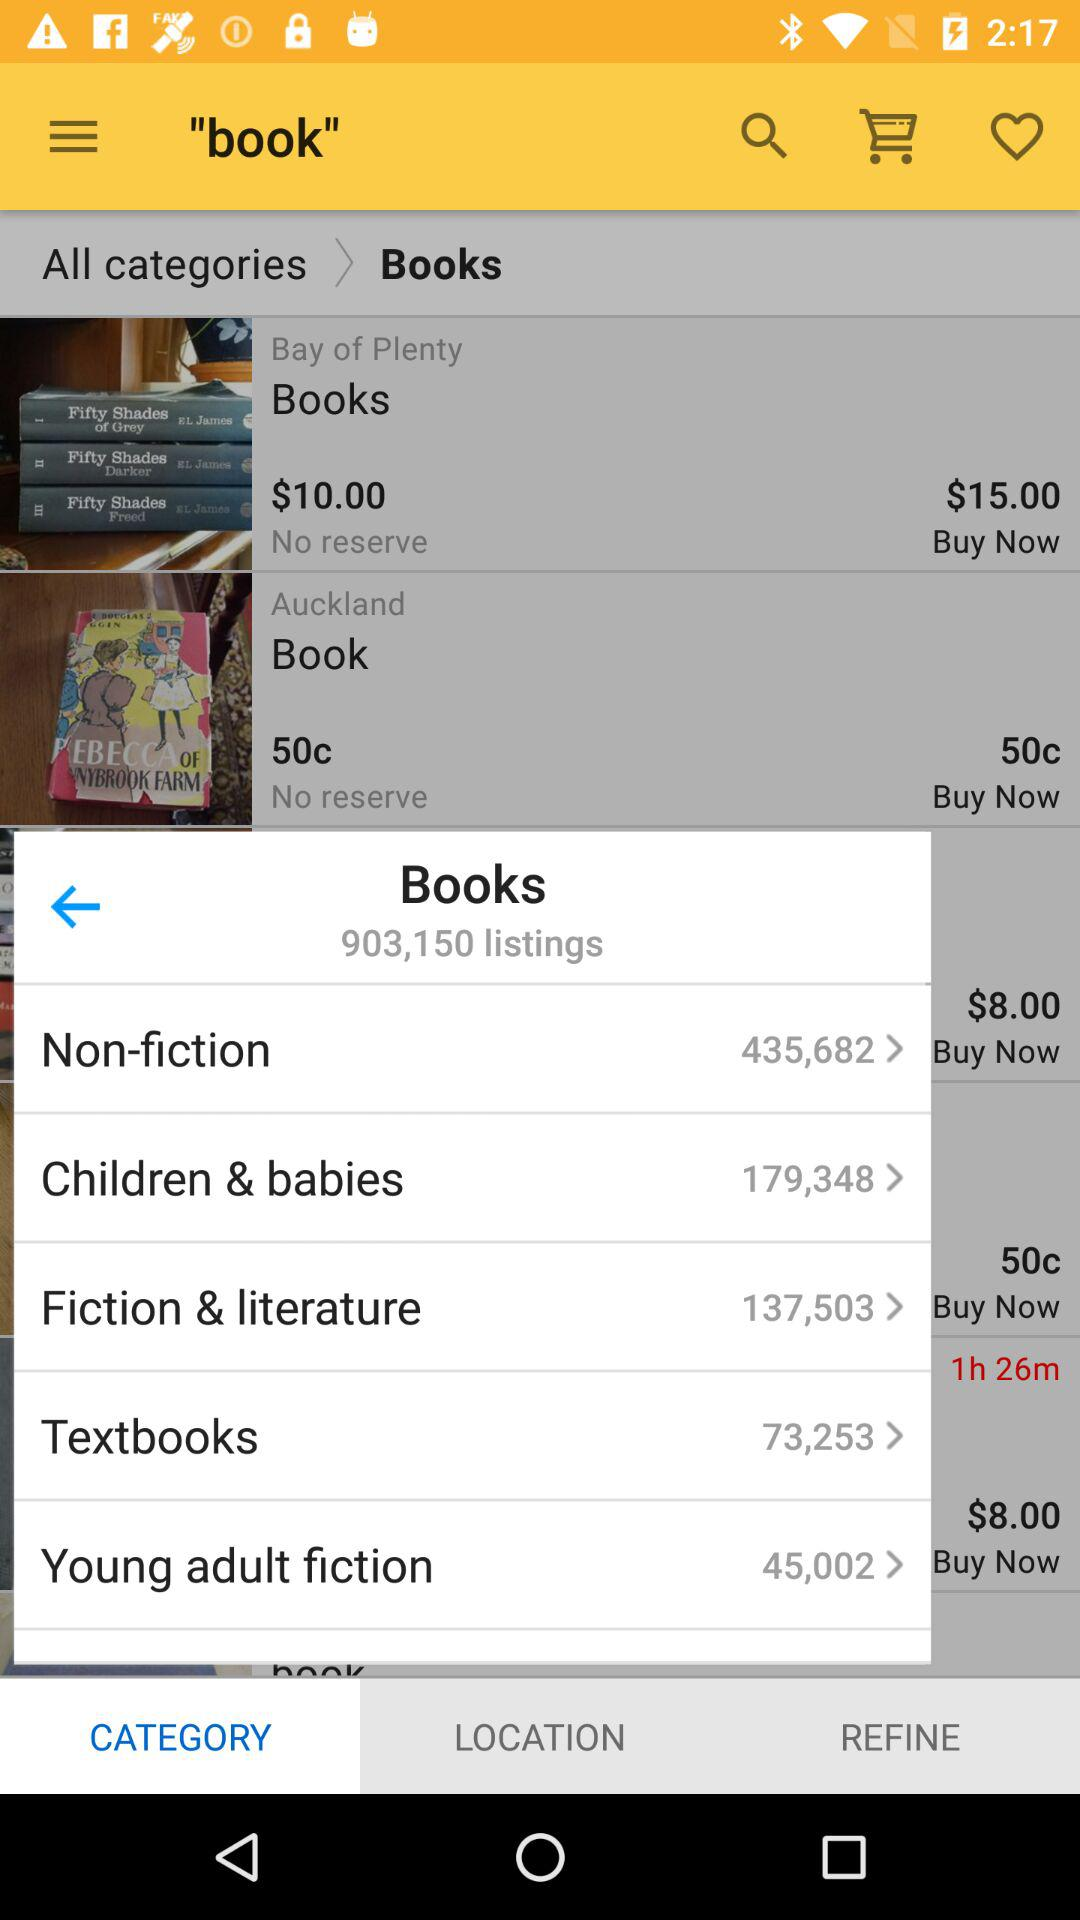What is the total number of book listings? There are 903,150 book listings. 